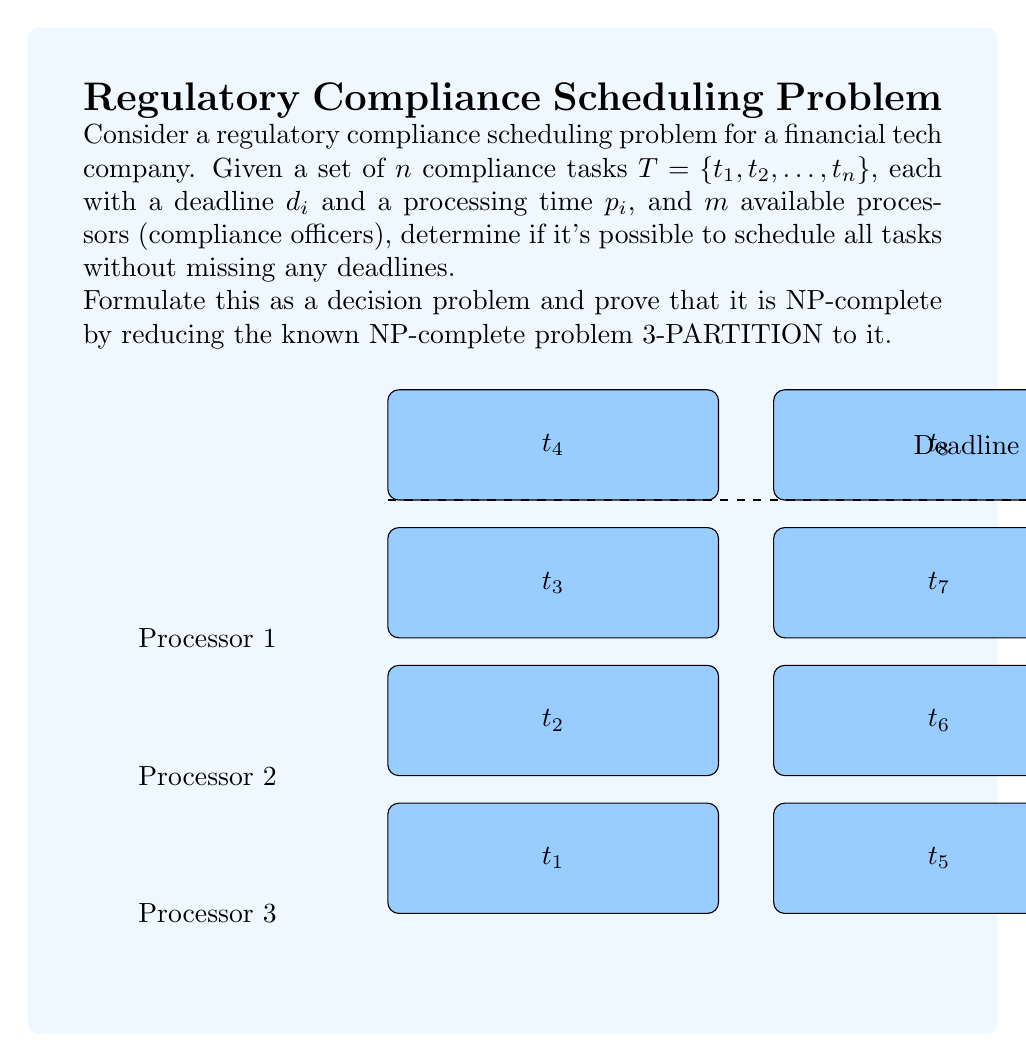Show me your answer to this math problem. To prove that this regulatory compliance scheduling problem is NP-complete, we'll follow these steps:

1) Show that the problem is in NP.
2) Choose a known NP-complete problem (3-PARTITION) and reduce it to our problem.

Step 1: The problem is in NP
A problem is in NP if we can verify a solution in polynomial time. For this scheduling problem, given a schedule, we can check if all tasks are assigned to processors and if they meet their deadlines in O(n) time, where n is the number of tasks. Thus, the problem is in NP.

Step 2: Reduction from 3-PARTITION
The 3-PARTITION problem is defined as follows:
Given a set $A$ of $3m$ positive integers $\{a_1, a_2, ..., a_{3m}\}$ and a bound $B$, can $A$ be partitioned into $m$ disjoint sets $S_1, S_2, ..., S_m$, each containing exactly three elements, such that the sum of the elements in each set is equal to $B$?

We'll reduce 3-PARTITION to our scheduling problem:

a) For each integer $a_i$ in the 3-PARTITION instance, create a task $t_i$ with processing time $p_i = a_i$.
b) Set the number of processors $m$ equal to the number of sets in 3-PARTITION.
c) Set a common deadline $d = B$ for all tasks.

The reduction is polynomial-time as we're creating one task per integer and setting a single deadline.

Now, we need to prove that a solution to 3-PARTITION exists if and only if there exists a valid schedule for our problem.

If 3-PARTITION has a solution:
- Each set $S_j$ in the 3-PARTITION solution corresponds to a processor in our scheduling problem.
- The three tasks corresponding to the elements in $S_j$ can be scheduled sequentially on processor $j$.
- Since the sum of elements in each set is $B$, all tasks on each processor will complete by the deadline $B$.

If our scheduling problem has a solution:
- Each processor's schedule corresponds to a set in the 3-PARTITION problem.
- Since all tasks meet the deadline $B$, the sum of processing times on each processor is at most $B$.
- As there are $3m$ tasks and $m$ processors, each processor must have exactly 3 tasks to utilize the full time $B$.
- Therefore, the tasks scheduled on each processor form a valid set for the 3-PARTITION problem.

This reduction proves that our regulatory compliance scheduling problem is at least as hard as 3-PARTITION. Since 3-PARTITION is NP-complete and our problem is in NP, our problem is NP-complete.
Answer: NP-complete 